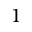<formula> <loc_0><loc_0><loc_500><loc_500>1</formula> 